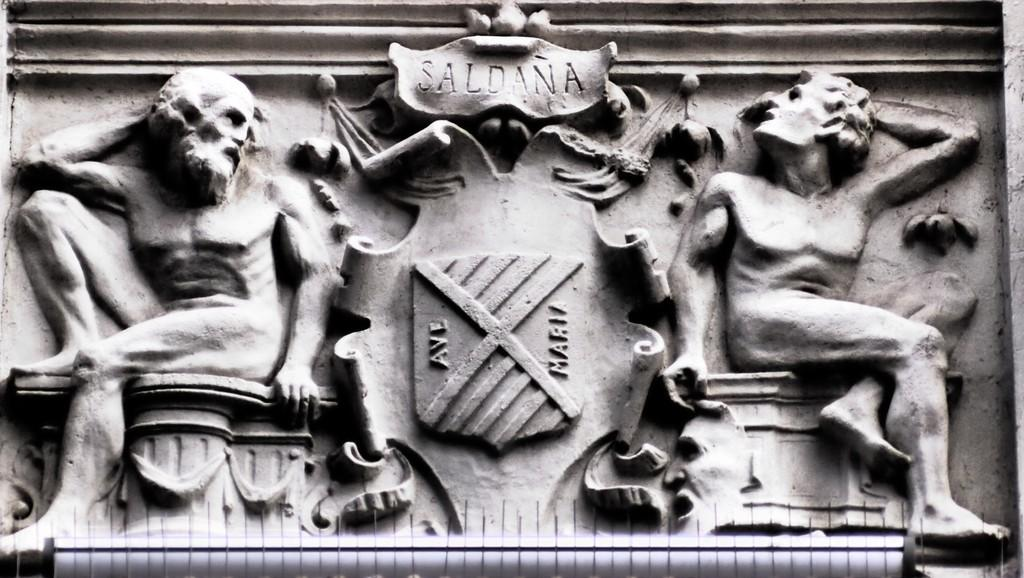Provide a one-sentence caption for the provided image. A stone carving of two men sitting with a banner reading saldana above. 